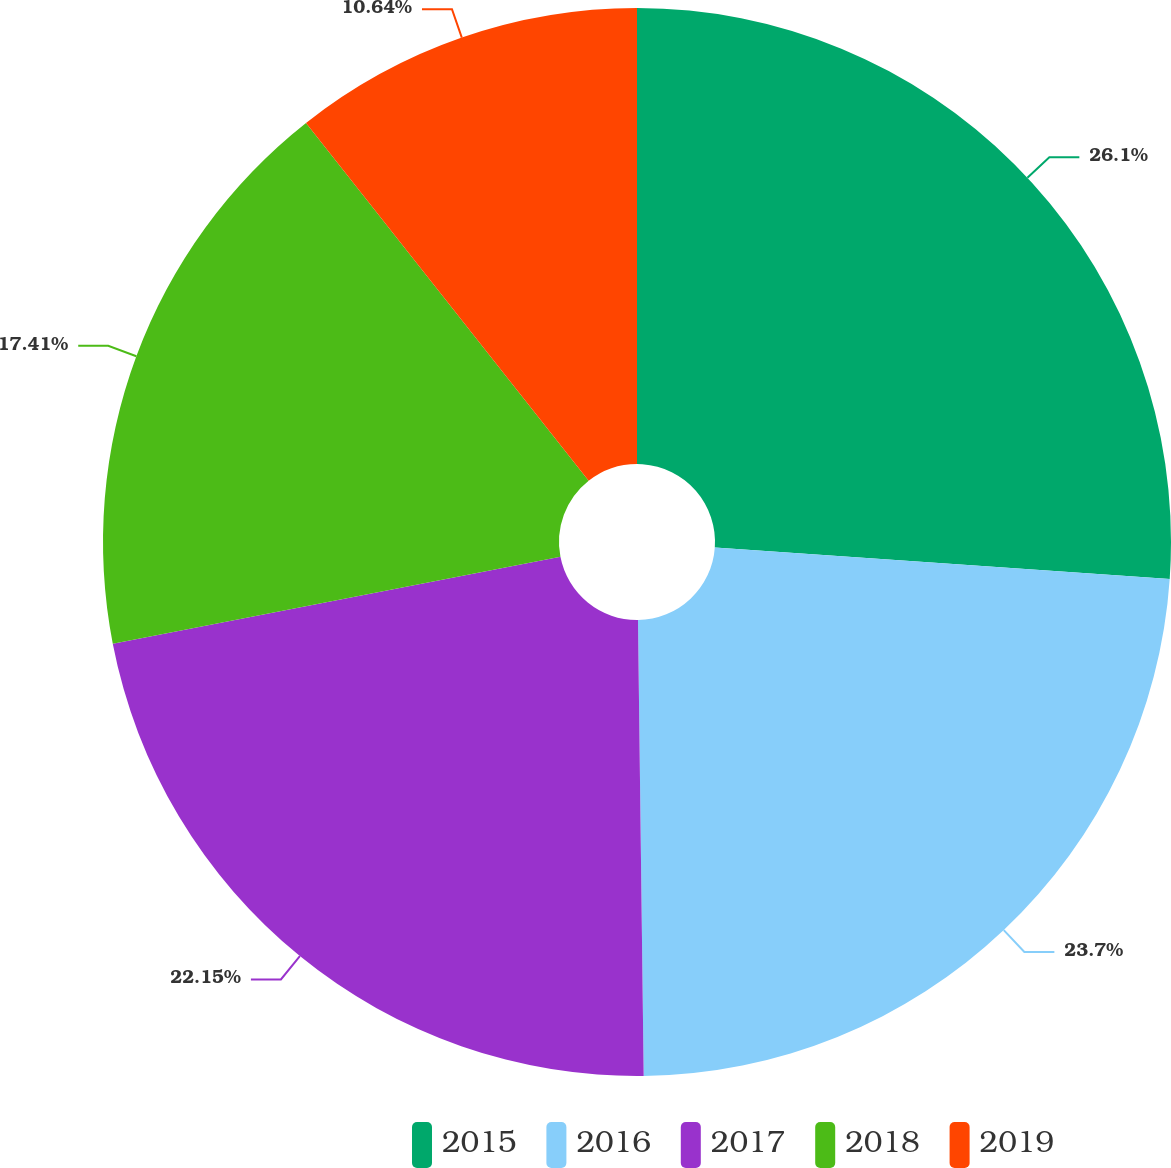Convert chart. <chart><loc_0><loc_0><loc_500><loc_500><pie_chart><fcel>2015<fcel>2016<fcel>2017<fcel>2018<fcel>2019<nl><fcel>26.1%<fcel>23.7%<fcel>22.15%<fcel>17.41%<fcel>10.64%<nl></chart> 